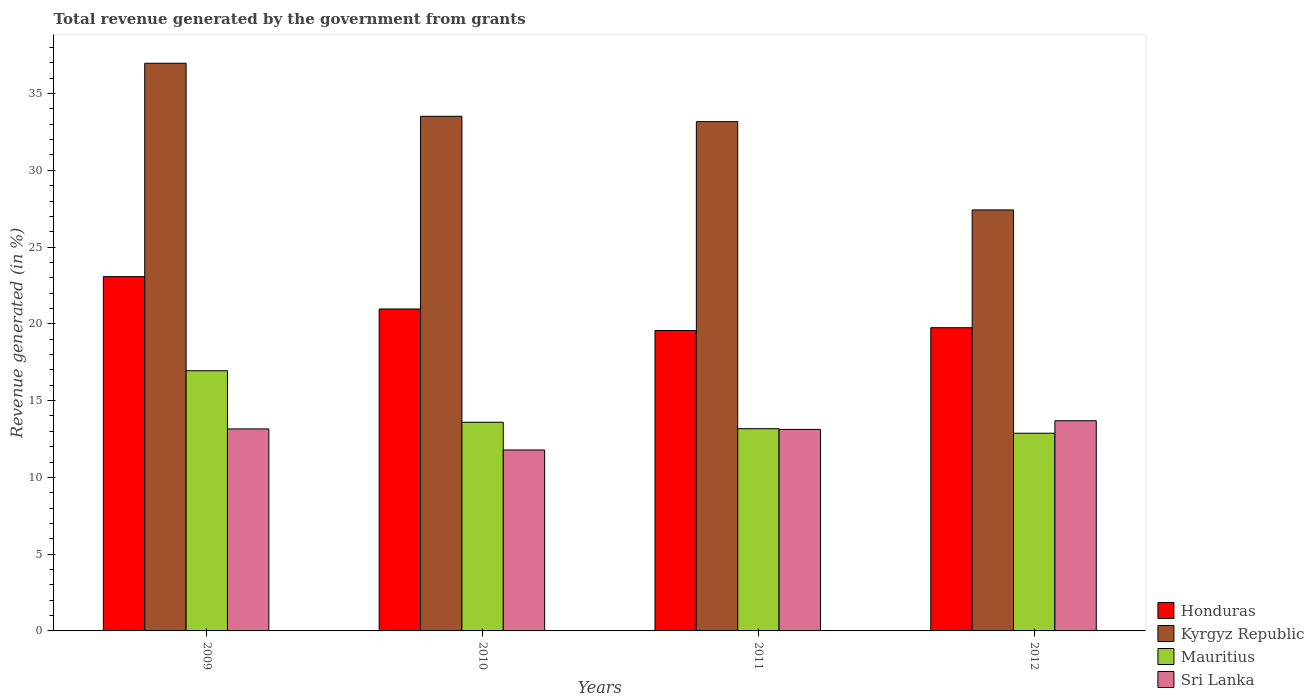How many different coloured bars are there?
Your answer should be compact. 4. How many bars are there on the 3rd tick from the right?
Your answer should be very brief. 4. What is the label of the 1st group of bars from the left?
Give a very brief answer. 2009. In how many cases, is the number of bars for a given year not equal to the number of legend labels?
Give a very brief answer. 0. What is the total revenue generated in Kyrgyz Republic in 2011?
Your answer should be compact. 33.17. Across all years, what is the maximum total revenue generated in Mauritius?
Give a very brief answer. 16.95. Across all years, what is the minimum total revenue generated in Honduras?
Provide a short and direct response. 19.57. What is the total total revenue generated in Honduras in the graph?
Provide a short and direct response. 83.36. What is the difference between the total revenue generated in Kyrgyz Republic in 2010 and that in 2012?
Offer a very short reply. 6.1. What is the difference between the total revenue generated in Mauritius in 2009 and the total revenue generated in Honduras in 2012?
Make the answer very short. -2.8. What is the average total revenue generated in Honduras per year?
Offer a very short reply. 20.84. In the year 2011, what is the difference between the total revenue generated in Kyrgyz Republic and total revenue generated in Mauritius?
Give a very brief answer. 20. In how many years, is the total revenue generated in Sri Lanka greater than 7 %?
Your answer should be very brief. 4. What is the ratio of the total revenue generated in Mauritius in 2009 to that in 2012?
Give a very brief answer. 1.32. Is the total revenue generated in Honduras in 2009 less than that in 2011?
Offer a terse response. No. Is the difference between the total revenue generated in Kyrgyz Republic in 2009 and 2012 greater than the difference between the total revenue generated in Mauritius in 2009 and 2012?
Provide a short and direct response. Yes. What is the difference between the highest and the second highest total revenue generated in Sri Lanka?
Provide a succinct answer. 0.53. What is the difference between the highest and the lowest total revenue generated in Sri Lanka?
Offer a very short reply. 1.9. Is the sum of the total revenue generated in Kyrgyz Republic in 2009 and 2010 greater than the maximum total revenue generated in Honduras across all years?
Your answer should be compact. Yes. What does the 1st bar from the left in 2011 represents?
Offer a terse response. Honduras. What does the 4th bar from the right in 2012 represents?
Keep it short and to the point. Honduras. Is it the case that in every year, the sum of the total revenue generated in Kyrgyz Republic and total revenue generated in Sri Lanka is greater than the total revenue generated in Mauritius?
Give a very brief answer. Yes. Are all the bars in the graph horizontal?
Make the answer very short. No. How many years are there in the graph?
Give a very brief answer. 4. Are the values on the major ticks of Y-axis written in scientific E-notation?
Provide a short and direct response. No. Does the graph contain any zero values?
Make the answer very short. No. Where does the legend appear in the graph?
Provide a short and direct response. Bottom right. What is the title of the graph?
Provide a short and direct response. Total revenue generated by the government from grants. Does "Congo (Democratic)" appear as one of the legend labels in the graph?
Offer a very short reply. No. What is the label or title of the Y-axis?
Give a very brief answer. Revenue generated (in %). What is the Revenue generated (in %) of Honduras in 2009?
Your response must be concise. 23.08. What is the Revenue generated (in %) in Kyrgyz Republic in 2009?
Your answer should be very brief. 36.97. What is the Revenue generated (in %) in Mauritius in 2009?
Keep it short and to the point. 16.95. What is the Revenue generated (in %) of Sri Lanka in 2009?
Provide a succinct answer. 13.16. What is the Revenue generated (in %) of Honduras in 2010?
Your answer should be very brief. 20.97. What is the Revenue generated (in %) of Kyrgyz Republic in 2010?
Your answer should be compact. 33.52. What is the Revenue generated (in %) in Mauritius in 2010?
Provide a succinct answer. 13.59. What is the Revenue generated (in %) of Sri Lanka in 2010?
Your answer should be compact. 11.79. What is the Revenue generated (in %) of Honduras in 2011?
Your answer should be compact. 19.57. What is the Revenue generated (in %) of Kyrgyz Republic in 2011?
Ensure brevity in your answer.  33.17. What is the Revenue generated (in %) in Mauritius in 2011?
Your answer should be compact. 13.17. What is the Revenue generated (in %) in Sri Lanka in 2011?
Ensure brevity in your answer.  13.13. What is the Revenue generated (in %) of Honduras in 2012?
Make the answer very short. 19.75. What is the Revenue generated (in %) in Kyrgyz Republic in 2012?
Provide a short and direct response. 27.42. What is the Revenue generated (in %) of Mauritius in 2012?
Offer a very short reply. 12.88. What is the Revenue generated (in %) in Sri Lanka in 2012?
Ensure brevity in your answer.  13.69. Across all years, what is the maximum Revenue generated (in %) of Honduras?
Offer a very short reply. 23.08. Across all years, what is the maximum Revenue generated (in %) of Kyrgyz Republic?
Give a very brief answer. 36.97. Across all years, what is the maximum Revenue generated (in %) in Mauritius?
Your answer should be very brief. 16.95. Across all years, what is the maximum Revenue generated (in %) of Sri Lanka?
Offer a very short reply. 13.69. Across all years, what is the minimum Revenue generated (in %) of Honduras?
Your answer should be compact. 19.57. Across all years, what is the minimum Revenue generated (in %) in Kyrgyz Republic?
Ensure brevity in your answer.  27.42. Across all years, what is the minimum Revenue generated (in %) of Mauritius?
Offer a very short reply. 12.88. Across all years, what is the minimum Revenue generated (in %) in Sri Lanka?
Your response must be concise. 11.79. What is the total Revenue generated (in %) in Honduras in the graph?
Provide a short and direct response. 83.36. What is the total Revenue generated (in %) in Kyrgyz Republic in the graph?
Provide a succinct answer. 131.09. What is the total Revenue generated (in %) in Mauritius in the graph?
Your response must be concise. 56.59. What is the total Revenue generated (in %) of Sri Lanka in the graph?
Ensure brevity in your answer.  51.76. What is the difference between the Revenue generated (in %) in Honduras in 2009 and that in 2010?
Provide a short and direct response. 2.11. What is the difference between the Revenue generated (in %) of Kyrgyz Republic in 2009 and that in 2010?
Make the answer very short. 3.45. What is the difference between the Revenue generated (in %) in Mauritius in 2009 and that in 2010?
Your answer should be compact. 3.36. What is the difference between the Revenue generated (in %) in Sri Lanka in 2009 and that in 2010?
Give a very brief answer. 1.37. What is the difference between the Revenue generated (in %) of Honduras in 2009 and that in 2011?
Offer a terse response. 3.51. What is the difference between the Revenue generated (in %) of Kyrgyz Republic in 2009 and that in 2011?
Provide a short and direct response. 3.8. What is the difference between the Revenue generated (in %) in Mauritius in 2009 and that in 2011?
Your response must be concise. 3.77. What is the difference between the Revenue generated (in %) in Sri Lanka in 2009 and that in 2011?
Your answer should be compact. 0.03. What is the difference between the Revenue generated (in %) in Honduras in 2009 and that in 2012?
Provide a succinct answer. 3.33. What is the difference between the Revenue generated (in %) in Kyrgyz Republic in 2009 and that in 2012?
Offer a very short reply. 9.55. What is the difference between the Revenue generated (in %) of Mauritius in 2009 and that in 2012?
Provide a short and direct response. 4.07. What is the difference between the Revenue generated (in %) in Sri Lanka in 2009 and that in 2012?
Give a very brief answer. -0.53. What is the difference between the Revenue generated (in %) of Honduras in 2010 and that in 2011?
Provide a short and direct response. 1.4. What is the difference between the Revenue generated (in %) of Kyrgyz Republic in 2010 and that in 2011?
Give a very brief answer. 0.35. What is the difference between the Revenue generated (in %) of Mauritius in 2010 and that in 2011?
Provide a succinct answer. 0.42. What is the difference between the Revenue generated (in %) of Sri Lanka in 2010 and that in 2011?
Your answer should be compact. -1.34. What is the difference between the Revenue generated (in %) of Honduras in 2010 and that in 2012?
Your answer should be compact. 1.22. What is the difference between the Revenue generated (in %) in Kyrgyz Republic in 2010 and that in 2012?
Your answer should be very brief. 6.1. What is the difference between the Revenue generated (in %) in Mauritius in 2010 and that in 2012?
Make the answer very short. 0.71. What is the difference between the Revenue generated (in %) in Sri Lanka in 2010 and that in 2012?
Ensure brevity in your answer.  -1.91. What is the difference between the Revenue generated (in %) in Honduras in 2011 and that in 2012?
Your response must be concise. -0.18. What is the difference between the Revenue generated (in %) in Kyrgyz Republic in 2011 and that in 2012?
Offer a terse response. 5.75. What is the difference between the Revenue generated (in %) in Mauritius in 2011 and that in 2012?
Give a very brief answer. 0.29. What is the difference between the Revenue generated (in %) of Sri Lanka in 2011 and that in 2012?
Offer a terse response. -0.57. What is the difference between the Revenue generated (in %) in Honduras in 2009 and the Revenue generated (in %) in Kyrgyz Republic in 2010?
Your answer should be compact. -10.44. What is the difference between the Revenue generated (in %) in Honduras in 2009 and the Revenue generated (in %) in Mauritius in 2010?
Give a very brief answer. 9.49. What is the difference between the Revenue generated (in %) in Honduras in 2009 and the Revenue generated (in %) in Sri Lanka in 2010?
Provide a succinct answer. 11.29. What is the difference between the Revenue generated (in %) in Kyrgyz Republic in 2009 and the Revenue generated (in %) in Mauritius in 2010?
Give a very brief answer. 23.38. What is the difference between the Revenue generated (in %) in Kyrgyz Republic in 2009 and the Revenue generated (in %) in Sri Lanka in 2010?
Keep it short and to the point. 25.19. What is the difference between the Revenue generated (in %) of Mauritius in 2009 and the Revenue generated (in %) of Sri Lanka in 2010?
Ensure brevity in your answer.  5.16. What is the difference between the Revenue generated (in %) in Honduras in 2009 and the Revenue generated (in %) in Kyrgyz Republic in 2011?
Give a very brief answer. -10.09. What is the difference between the Revenue generated (in %) of Honduras in 2009 and the Revenue generated (in %) of Mauritius in 2011?
Give a very brief answer. 9.91. What is the difference between the Revenue generated (in %) of Honduras in 2009 and the Revenue generated (in %) of Sri Lanka in 2011?
Give a very brief answer. 9.95. What is the difference between the Revenue generated (in %) in Kyrgyz Republic in 2009 and the Revenue generated (in %) in Mauritius in 2011?
Ensure brevity in your answer.  23.8. What is the difference between the Revenue generated (in %) of Kyrgyz Republic in 2009 and the Revenue generated (in %) of Sri Lanka in 2011?
Give a very brief answer. 23.85. What is the difference between the Revenue generated (in %) in Mauritius in 2009 and the Revenue generated (in %) in Sri Lanka in 2011?
Your response must be concise. 3.82. What is the difference between the Revenue generated (in %) of Honduras in 2009 and the Revenue generated (in %) of Kyrgyz Republic in 2012?
Provide a succinct answer. -4.34. What is the difference between the Revenue generated (in %) of Honduras in 2009 and the Revenue generated (in %) of Mauritius in 2012?
Offer a terse response. 10.2. What is the difference between the Revenue generated (in %) in Honduras in 2009 and the Revenue generated (in %) in Sri Lanka in 2012?
Your answer should be very brief. 9.39. What is the difference between the Revenue generated (in %) of Kyrgyz Republic in 2009 and the Revenue generated (in %) of Mauritius in 2012?
Your answer should be compact. 24.1. What is the difference between the Revenue generated (in %) of Kyrgyz Republic in 2009 and the Revenue generated (in %) of Sri Lanka in 2012?
Keep it short and to the point. 23.28. What is the difference between the Revenue generated (in %) in Mauritius in 2009 and the Revenue generated (in %) in Sri Lanka in 2012?
Give a very brief answer. 3.26. What is the difference between the Revenue generated (in %) of Honduras in 2010 and the Revenue generated (in %) of Kyrgyz Republic in 2011?
Offer a terse response. -12.2. What is the difference between the Revenue generated (in %) in Honduras in 2010 and the Revenue generated (in %) in Mauritius in 2011?
Your response must be concise. 7.8. What is the difference between the Revenue generated (in %) in Honduras in 2010 and the Revenue generated (in %) in Sri Lanka in 2011?
Your answer should be compact. 7.84. What is the difference between the Revenue generated (in %) in Kyrgyz Republic in 2010 and the Revenue generated (in %) in Mauritius in 2011?
Keep it short and to the point. 20.35. What is the difference between the Revenue generated (in %) of Kyrgyz Republic in 2010 and the Revenue generated (in %) of Sri Lanka in 2011?
Give a very brief answer. 20.4. What is the difference between the Revenue generated (in %) of Mauritius in 2010 and the Revenue generated (in %) of Sri Lanka in 2011?
Keep it short and to the point. 0.47. What is the difference between the Revenue generated (in %) in Honduras in 2010 and the Revenue generated (in %) in Kyrgyz Republic in 2012?
Provide a succinct answer. -6.45. What is the difference between the Revenue generated (in %) of Honduras in 2010 and the Revenue generated (in %) of Mauritius in 2012?
Offer a very short reply. 8.09. What is the difference between the Revenue generated (in %) in Honduras in 2010 and the Revenue generated (in %) in Sri Lanka in 2012?
Give a very brief answer. 7.28. What is the difference between the Revenue generated (in %) of Kyrgyz Republic in 2010 and the Revenue generated (in %) of Mauritius in 2012?
Your answer should be compact. 20.64. What is the difference between the Revenue generated (in %) in Kyrgyz Republic in 2010 and the Revenue generated (in %) in Sri Lanka in 2012?
Your response must be concise. 19.83. What is the difference between the Revenue generated (in %) of Mauritius in 2010 and the Revenue generated (in %) of Sri Lanka in 2012?
Give a very brief answer. -0.1. What is the difference between the Revenue generated (in %) in Honduras in 2011 and the Revenue generated (in %) in Kyrgyz Republic in 2012?
Give a very brief answer. -7.85. What is the difference between the Revenue generated (in %) of Honduras in 2011 and the Revenue generated (in %) of Mauritius in 2012?
Ensure brevity in your answer.  6.69. What is the difference between the Revenue generated (in %) of Honduras in 2011 and the Revenue generated (in %) of Sri Lanka in 2012?
Offer a terse response. 5.88. What is the difference between the Revenue generated (in %) in Kyrgyz Republic in 2011 and the Revenue generated (in %) in Mauritius in 2012?
Provide a succinct answer. 20.3. What is the difference between the Revenue generated (in %) of Kyrgyz Republic in 2011 and the Revenue generated (in %) of Sri Lanka in 2012?
Your answer should be compact. 19.48. What is the difference between the Revenue generated (in %) of Mauritius in 2011 and the Revenue generated (in %) of Sri Lanka in 2012?
Offer a terse response. -0.52. What is the average Revenue generated (in %) of Honduras per year?
Your answer should be very brief. 20.84. What is the average Revenue generated (in %) in Kyrgyz Republic per year?
Offer a very short reply. 32.77. What is the average Revenue generated (in %) in Mauritius per year?
Your answer should be very brief. 14.15. What is the average Revenue generated (in %) in Sri Lanka per year?
Provide a short and direct response. 12.94. In the year 2009, what is the difference between the Revenue generated (in %) in Honduras and Revenue generated (in %) in Kyrgyz Republic?
Ensure brevity in your answer.  -13.9. In the year 2009, what is the difference between the Revenue generated (in %) in Honduras and Revenue generated (in %) in Mauritius?
Give a very brief answer. 6.13. In the year 2009, what is the difference between the Revenue generated (in %) of Honduras and Revenue generated (in %) of Sri Lanka?
Your answer should be compact. 9.92. In the year 2009, what is the difference between the Revenue generated (in %) of Kyrgyz Republic and Revenue generated (in %) of Mauritius?
Make the answer very short. 20.03. In the year 2009, what is the difference between the Revenue generated (in %) in Kyrgyz Republic and Revenue generated (in %) in Sri Lanka?
Ensure brevity in your answer.  23.82. In the year 2009, what is the difference between the Revenue generated (in %) of Mauritius and Revenue generated (in %) of Sri Lanka?
Give a very brief answer. 3.79. In the year 2010, what is the difference between the Revenue generated (in %) of Honduras and Revenue generated (in %) of Kyrgyz Republic?
Keep it short and to the point. -12.55. In the year 2010, what is the difference between the Revenue generated (in %) of Honduras and Revenue generated (in %) of Mauritius?
Your response must be concise. 7.38. In the year 2010, what is the difference between the Revenue generated (in %) in Honduras and Revenue generated (in %) in Sri Lanka?
Provide a succinct answer. 9.18. In the year 2010, what is the difference between the Revenue generated (in %) in Kyrgyz Republic and Revenue generated (in %) in Mauritius?
Your answer should be compact. 19.93. In the year 2010, what is the difference between the Revenue generated (in %) in Kyrgyz Republic and Revenue generated (in %) in Sri Lanka?
Offer a very short reply. 21.73. In the year 2010, what is the difference between the Revenue generated (in %) of Mauritius and Revenue generated (in %) of Sri Lanka?
Your answer should be very brief. 1.8. In the year 2011, what is the difference between the Revenue generated (in %) in Honduras and Revenue generated (in %) in Kyrgyz Republic?
Ensure brevity in your answer.  -13.61. In the year 2011, what is the difference between the Revenue generated (in %) in Honduras and Revenue generated (in %) in Mauritius?
Ensure brevity in your answer.  6.39. In the year 2011, what is the difference between the Revenue generated (in %) of Honduras and Revenue generated (in %) of Sri Lanka?
Provide a short and direct response. 6.44. In the year 2011, what is the difference between the Revenue generated (in %) in Kyrgyz Republic and Revenue generated (in %) in Mauritius?
Your answer should be very brief. 20. In the year 2011, what is the difference between the Revenue generated (in %) of Kyrgyz Republic and Revenue generated (in %) of Sri Lanka?
Provide a succinct answer. 20.05. In the year 2011, what is the difference between the Revenue generated (in %) in Mauritius and Revenue generated (in %) in Sri Lanka?
Ensure brevity in your answer.  0.05. In the year 2012, what is the difference between the Revenue generated (in %) in Honduras and Revenue generated (in %) in Kyrgyz Republic?
Your answer should be compact. -7.67. In the year 2012, what is the difference between the Revenue generated (in %) of Honduras and Revenue generated (in %) of Mauritius?
Give a very brief answer. 6.87. In the year 2012, what is the difference between the Revenue generated (in %) of Honduras and Revenue generated (in %) of Sri Lanka?
Ensure brevity in your answer.  6.06. In the year 2012, what is the difference between the Revenue generated (in %) of Kyrgyz Republic and Revenue generated (in %) of Mauritius?
Your answer should be compact. 14.54. In the year 2012, what is the difference between the Revenue generated (in %) in Kyrgyz Republic and Revenue generated (in %) in Sri Lanka?
Provide a short and direct response. 13.73. In the year 2012, what is the difference between the Revenue generated (in %) in Mauritius and Revenue generated (in %) in Sri Lanka?
Your response must be concise. -0.81. What is the ratio of the Revenue generated (in %) of Honduras in 2009 to that in 2010?
Your answer should be compact. 1.1. What is the ratio of the Revenue generated (in %) in Kyrgyz Republic in 2009 to that in 2010?
Your response must be concise. 1.1. What is the ratio of the Revenue generated (in %) of Mauritius in 2009 to that in 2010?
Your response must be concise. 1.25. What is the ratio of the Revenue generated (in %) of Sri Lanka in 2009 to that in 2010?
Your answer should be compact. 1.12. What is the ratio of the Revenue generated (in %) in Honduras in 2009 to that in 2011?
Ensure brevity in your answer.  1.18. What is the ratio of the Revenue generated (in %) in Kyrgyz Republic in 2009 to that in 2011?
Offer a very short reply. 1.11. What is the ratio of the Revenue generated (in %) of Mauritius in 2009 to that in 2011?
Your response must be concise. 1.29. What is the ratio of the Revenue generated (in %) in Honduras in 2009 to that in 2012?
Offer a very short reply. 1.17. What is the ratio of the Revenue generated (in %) of Kyrgyz Republic in 2009 to that in 2012?
Provide a short and direct response. 1.35. What is the ratio of the Revenue generated (in %) in Mauritius in 2009 to that in 2012?
Your response must be concise. 1.32. What is the ratio of the Revenue generated (in %) of Honduras in 2010 to that in 2011?
Your response must be concise. 1.07. What is the ratio of the Revenue generated (in %) in Kyrgyz Republic in 2010 to that in 2011?
Offer a very short reply. 1.01. What is the ratio of the Revenue generated (in %) of Mauritius in 2010 to that in 2011?
Give a very brief answer. 1.03. What is the ratio of the Revenue generated (in %) in Sri Lanka in 2010 to that in 2011?
Give a very brief answer. 0.9. What is the ratio of the Revenue generated (in %) in Honduras in 2010 to that in 2012?
Keep it short and to the point. 1.06. What is the ratio of the Revenue generated (in %) of Kyrgyz Republic in 2010 to that in 2012?
Give a very brief answer. 1.22. What is the ratio of the Revenue generated (in %) in Mauritius in 2010 to that in 2012?
Your answer should be very brief. 1.06. What is the ratio of the Revenue generated (in %) of Sri Lanka in 2010 to that in 2012?
Your answer should be very brief. 0.86. What is the ratio of the Revenue generated (in %) of Kyrgyz Republic in 2011 to that in 2012?
Provide a succinct answer. 1.21. What is the ratio of the Revenue generated (in %) of Mauritius in 2011 to that in 2012?
Make the answer very short. 1.02. What is the ratio of the Revenue generated (in %) in Sri Lanka in 2011 to that in 2012?
Your response must be concise. 0.96. What is the difference between the highest and the second highest Revenue generated (in %) of Honduras?
Provide a succinct answer. 2.11. What is the difference between the highest and the second highest Revenue generated (in %) in Kyrgyz Republic?
Keep it short and to the point. 3.45. What is the difference between the highest and the second highest Revenue generated (in %) in Mauritius?
Keep it short and to the point. 3.36. What is the difference between the highest and the second highest Revenue generated (in %) of Sri Lanka?
Ensure brevity in your answer.  0.53. What is the difference between the highest and the lowest Revenue generated (in %) in Honduras?
Provide a short and direct response. 3.51. What is the difference between the highest and the lowest Revenue generated (in %) of Kyrgyz Republic?
Keep it short and to the point. 9.55. What is the difference between the highest and the lowest Revenue generated (in %) in Mauritius?
Your response must be concise. 4.07. What is the difference between the highest and the lowest Revenue generated (in %) of Sri Lanka?
Ensure brevity in your answer.  1.91. 